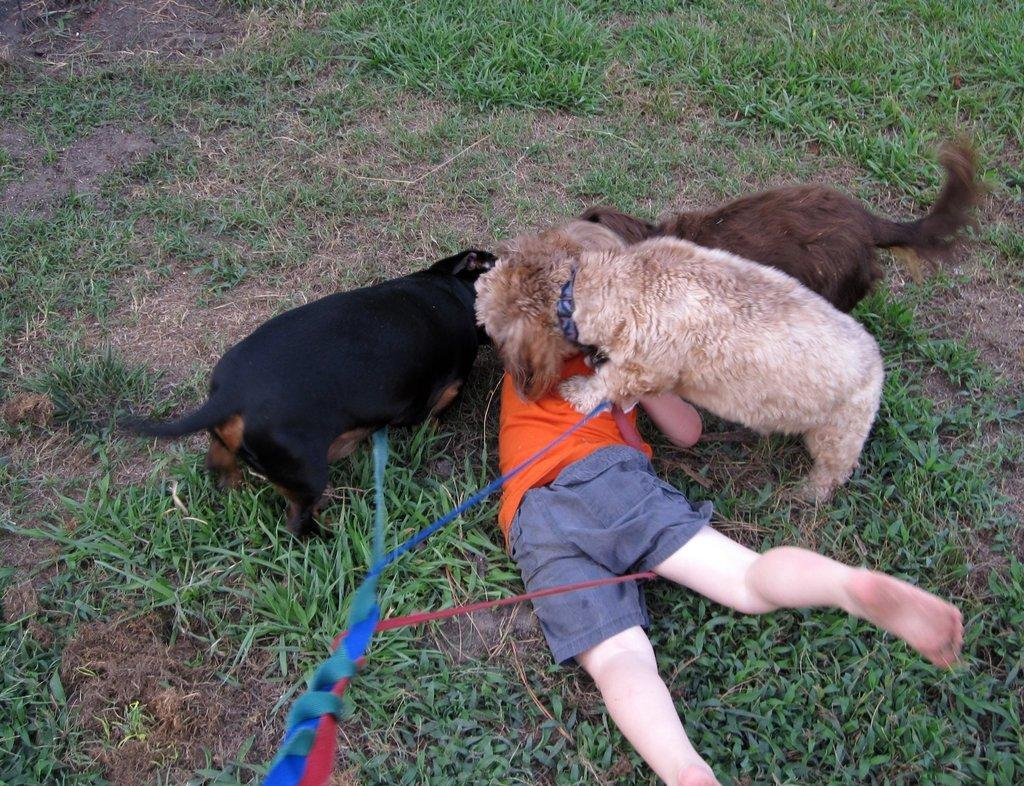What is the main subject of the image? There is a person on the ground in the image. How many dogs are present in the image? There are three dogs in the image. What are the dogs doing to the person? The dogs are biting the person. What type of surface is the person and dogs on? There is grass on the ground in the image. What type of haircut is the person getting from the dogs in the image? There is no haircut being given in the image; the dogs are biting the person. Can you tell me how many times the person rolls over in the image? There is no indication that the person rolls over in the image; they are on the ground being bitten by the dogs. 